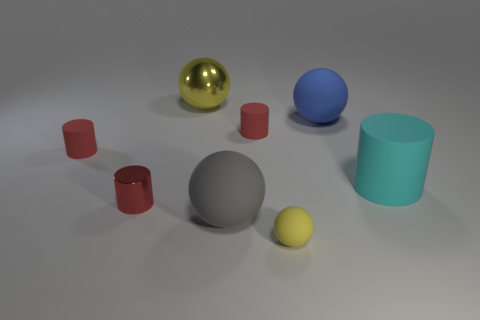Are there fewer big gray rubber things than gray shiny spheres? Actually, upon closer inspection of the image, it appears that there is an equal number of big gray rubber objects and gray shiny spheres - there is one large gray sphere which is rubbery in texture, and one smaller shiny gray sphere with a reflective surface. 